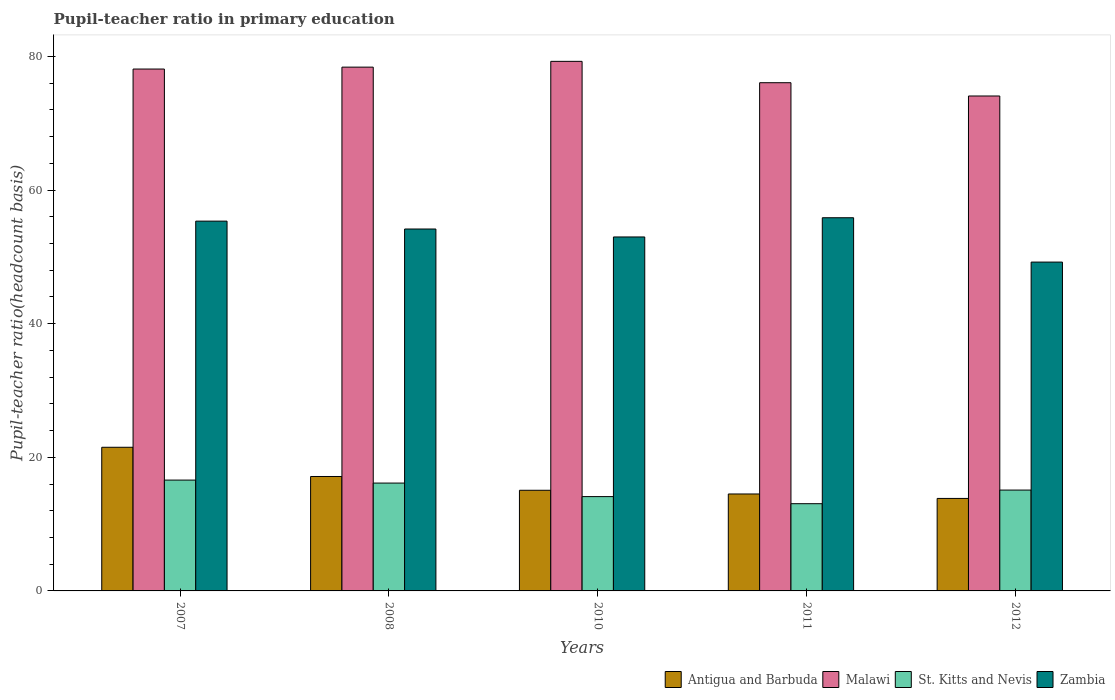How many different coloured bars are there?
Offer a very short reply. 4. Are the number of bars per tick equal to the number of legend labels?
Your response must be concise. Yes. Are the number of bars on each tick of the X-axis equal?
Provide a succinct answer. Yes. How many bars are there on the 1st tick from the left?
Keep it short and to the point. 4. What is the label of the 4th group of bars from the left?
Provide a succinct answer. 2011. What is the pupil-teacher ratio in primary education in Antigua and Barbuda in 2011?
Provide a short and direct response. 14.51. Across all years, what is the maximum pupil-teacher ratio in primary education in St. Kitts and Nevis?
Your answer should be very brief. 16.59. Across all years, what is the minimum pupil-teacher ratio in primary education in Zambia?
Provide a short and direct response. 49.22. What is the total pupil-teacher ratio in primary education in Malawi in the graph?
Offer a very short reply. 385.96. What is the difference between the pupil-teacher ratio in primary education in St. Kitts and Nevis in 2007 and that in 2010?
Your answer should be very brief. 2.47. What is the difference between the pupil-teacher ratio in primary education in Malawi in 2007 and the pupil-teacher ratio in primary education in St. Kitts and Nevis in 2010?
Provide a succinct answer. 64. What is the average pupil-teacher ratio in primary education in Malawi per year?
Keep it short and to the point. 77.19. In the year 2007, what is the difference between the pupil-teacher ratio in primary education in St. Kitts and Nevis and pupil-teacher ratio in primary education in Malawi?
Your answer should be very brief. -61.53. What is the ratio of the pupil-teacher ratio in primary education in Malawi in 2007 to that in 2010?
Offer a terse response. 0.99. What is the difference between the highest and the second highest pupil-teacher ratio in primary education in Malawi?
Offer a terse response. 0.87. What is the difference between the highest and the lowest pupil-teacher ratio in primary education in St. Kitts and Nevis?
Make the answer very short. 3.53. Is the sum of the pupil-teacher ratio in primary education in Malawi in 2008 and 2011 greater than the maximum pupil-teacher ratio in primary education in Antigua and Barbuda across all years?
Your answer should be compact. Yes. What does the 1st bar from the left in 2012 represents?
Give a very brief answer. Antigua and Barbuda. What does the 4th bar from the right in 2008 represents?
Provide a short and direct response. Antigua and Barbuda. Is it the case that in every year, the sum of the pupil-teacher ratio in primary education in Malawi and pupil-teacher ratio in primary education in St. Kitts and Nevis is greater than the pupil-teacher ratio in primary education in Antigua and Barbuda?
Ensure brevity in your answer.  Yes. Are all the bars in the graph horizontal?
Give a very brief answer. No. How many years are there in the graph?
Keep it short and to the point. 5. Does the graph contain any zero values?
Offer a terse response. No. Where does the legend appear in the graph?
Provide a short and direct response. Bottom right. How many legend labels are there?
Give a very brief answer. 4. What is the title of the graph?
Offer a terse response. Pupil-teacher ratio in primary education. Does "Aruba" appear as one of the legend labels in the graph?
Offer a terse response. No. What is the label or title of the X-axis?
Offer a terse response. Years. What is the label or title of the Y-axis?
Your response must be concise. Pupil-teacher ratio(headcount basis). What is the Pupil-teacher ratio(headcount basis) in Antigua and Barbuda in 2007?
Your answer should be compact. 21.5. What is the Pupil-teacher ratio(headcount basis) in Malawi in 2007?
Ensure brevity in your answer.  78.12. What is the Pupil-teacher ratio(headcount basis) in St. Kitts and Nevis in 2007?
Your response must be concise. 16.59. What is the Pupil-teacher ratio(headcount basis) of Zambia in 2007?
Provide a short and direct response. 55.35. What is the Pupil-teacher ratio(headcount basis) of Antigua and Barbuda in 2008?
Provide a short and direct response. 17.13. What is the Pupil-teacher ratio(headcount basis) of Malawi in 2008?
Your response must be concise. 78.41. What is the Pupil-teacher ratio(headcount basis) in St. Kitts and Nevis in 2008?
Your response must be concise. 16.14. What is the Pupil-teacher ratio(headcount basis) in Zambia in 2008?
Provide a succinct answer. 54.18. What is the Pupil-teacher ratio(headcount basis) in Antigua and Barbuda in 2010?
Keep it short and to the point. 15.07. What is the Pupil-teacher ratio(headcount basis) of Malawi in 2010?
Make the answer very short. 79.27. What is the Pupil-teacher ratio(headcount basis) of St. Kitts and Nevis in 2010?
Ensure brevity in your answer.  14.12. What is the Pupil-teacher ratio(headcount basis) of Zambia in 2010?
Provide a succinct answer. 52.99. What is the Pupil-teacher ratio(headcount basis) in Antigua and Barbuda in 2011?
Provide a succinct answer. 14.51. What is the Pupil-teacher ratio(headcount basis) of Malawi in 2011?
Offer a very short reply. 76.07. What is the Pupil-teacher ratio(headcount basis) in St. Kitts and Nevis in 2011?
Your response must be concise. 13.06. What is the Pupil-teacher ratio(headcount basis) of Zambia in 2011?
Offer a terse response. 55.86. What is the Pupil-teacher ratio(headcount basis) of Antigua and Barbuda in 2012?
Your answer should be compact. 13.85. What is the Pupil-teacher ratio(headcount basis) of Malawi in 2012?
Your response must be concise. 74.09. What is the Pupil-teacher ratio(headcount basis) in St. Kitts and Nevis in 2012?
Offer a very short reply. 15.1. What is the Pupil-teacher ratio(headcount basis) of Zambia in 2012?
Provide a succinct answer. 49.22. Across all years, what is the maximum Pupil-teacher ratio(headcount basis) of Antigua and Barbuda?
Give a very brief answer. 21.5. Across all years, what is the maximum Pupil-teacher ratio(headcount basis) in Malawi?
Your answer should be compact. 79.27. Across all years, what is the maximum Pupil-teacher ratio(headcount basis) in St. Kitts and Nevis?
Keep it short and to the point. 16.59. Across all years, what is the maximum Pupil-teacher ratio(headcount basis) in Zambia?
Offer a very short reply. 55.86. Across all years, what is the minimum Pupil-teacher ratio(headcount basis) of Antigua and Barbuda?
Keep it short and to the point. 13.85. Across all years, what is the minimum Pupil-teacher ratio(headcount basis) of Malawi?
Your answer should be very brief. 74.09. Across all years, what is the minimum Pupil-teacher ratio(headcount basis) in St. Kitts and Nevis?
Provide a succinct answer. 13.06. Across all years, what is the minimum Pupil-teacher ratio(headcount basis) of Zambia?
Ensure brevity in your answer.  49.22. What is the total Pupil-teacher ratio(headcount basis) of Antigua and Barbuda in the graph?
Your answer should be very brief. 82.06. What is the total Pupil-teacher ratio(headcount basis) in Malawi in the graph?
Keep it short and to the point. 385.96. What is the total Pupil-teacher ratio(headcount basis) of St. Kitts and Nevis in the graph?
Your answer should be very brief. 75.01. What is the total Pupil-teacher ratio(headcount basis) of Zambia in the graph?
Your answer should be compact. 267.6. What is the difference between the Pupil-teacher ratio(headcount basis) in Antigua and Barbuda in 2007 and that in 2008?
Your response must be concise. 4.37. What is the difference between the Pupil-teacher ratio(headcount basis) in Malawi in 2007 and that in 2008?
Offer a very short reply. -0.28. What is the difference between the Pupil-teacher ratio(headcount basis) in St. Kitts and Nevis in 2007 and that in 2008?
Offer a terse response. 0.45. What is the difference between the Pupil-teacher ratio(headcount basis) of Zambia in 2007 and that in 2008?
Your response must be concise. 1.18. What is the difference between the Pupil-teacher ratio(headcount basis) in Antigua and Barbuda in 2007 and that in 2010?
Offer a terse response. 6.44. What is the difference between the Pupil-teacher ratio(headcount basis) in Malawi in 2007 and that in 2010?
Keep it short and to the point. -1.15. What is the difference between the Pupil-teacher ratio(headcount basis) of St. Kitts and Nevis in 2007 and that in 2010?
Offer a terse response. 2.47. What is the difference between the Pupil-teacher ratio(headcount basis) in Zambia in 2007 and that in 2010?
Offer a terse response. 2.37. What is the difference between the Pupil-teacher ratio(headcount basis) of Antigua and Barbuda in 2007 and that in 2011?
Your response must be concise. 6.99. What is the difference between the Pupil-teacher ratio(headcount basis) of Malawi in 2007 and that in 2011?
Offer a very short reply. 2.05. What is the difference between the Pupil-teacher ratio(headcount basis) of St. Kitts and Nevis in 2007 and that in 2011?
Make the answer very short. 3.53. What is the difference between the Pupil-teacher ratio(headcount basis) in Zambia in 2007 and that in 2011?
Give a very brief answer. -0.51. What is the difference between the Pupil-teacher ratio(headcount basis) of Antigua and Barbuda in 2007 and that in 2012?
Make the answer very short. 7.66. What is the difference between the Pupil-teacher ratio(headcount basis) of Malawi in 2007 and that in 2012?
Ensure brevity in your answer.  4.04. What is the difference between the Pupil-teacher ratio(headcount basis) of St. Kitts and Nevis in 2007 and that in 2012?
Your answer should be compact. 1.5. What is the difference between the Pupil-teacher ratio(headcount basis) of Zambia in 2007 and that in 2012?
Your answer should be very brief. 6.13. What is the difference between the Pupil-teacher ratio(headcount basis) in Antigua and Barbuda in 2008 and that in 2010?
Make the answer very short. 2.06. What is the difference between the Pupil-teacher ratio(headcount basis) of Malawi in 2008 and that in 2010?
Provide a short and direct response. -0.87. What is the difference between the Pupil-teacher ratio(headcount basis) of St. Kitts and Nevis in 2008 and that in 2010?
Make the answer very short. 2.02. What is the difference between the Pupil-teacher ratio(headcount basis) of Zambia in 2008 and that in 2010?
Ensure brevity in your answer.  1.19. What is the difference between the Pupil-teacher ratio(headcount basis) in Antigua and Barbuda in 2008 and that in 2011?
Your answer should be very brief. 2.62. What is the difference between the Pupil-teacher ratio(headcount basis) of Malawi in 2008 and that in 2011?
Your answer should be compact. 2.33. What is the difference between the Pupil-teacher ratio(headcount basis) in St. Kitts and Nevis in 2008 and that in 2011?
Give a very brief answer. 3.09. What is the difference between the Pupil-teacher ratio(headcount basis) of Zambia in 2008 and that in 2011?
Keep it short and to the point. -1.69. What is the difference between the Pupil-teacher ratio(headcount basis) in Antigua and Barbuda in 2008 and that in 2012?
Keep it short and to the point. 3.28. What is the difference between the Pupil-teacher ratio(headcount basis) of Malawi in 2008 and that in 2012?
Make the answer very short. 4.32. What is the difference between the Pupil-teacher ratio(headcount basis) of St. Kitts and Nevis in 2008 and that in 2012?
Keep it short and to the point. 1.05. What is the difference between the Pupil-teacher ratio(headcount basis) in Zambia in 2008 and that in 2012?
Give a very brief answer. 4.95. What is the difference between the Pupil-teacher ratio(headcount basis) of Antigua and Barbuda in 2010 and that in 2011?
Provide a short and direct response. 0.55. What is the difference between the Pupil-teacher ratio(headcount basis) of Malawi in 2010 and that in 2011?
Ensure brevity in your answer.  3.2. What is the difference between the Pupil-teacher ratio(headcount basis) of St. Kitts and Nevis in 2010 and that in 2011?
Your response must be concise. 1.06. What is the difference between the Pupil-teacher ratio(headcount basis) of Zambia in 2010 and that in 2011?
Offer a very short reply. -2.88. What is the difference between the Pupil-teacher ratio(headcount basis) of Antigua and Barbuda in 2010 and that in 2012?
Provide a succinct answer. 1.22. What is the difference between the Pupil-teacher ratio(headcount basis) of Malawi in 2010 and that in 2012?
Offer a terse response. 5.19. What is the difference between the Pupil-teacher ratio(headcount basis) of St. Kitts and Nevis in 2010 and that in 2012?
Keep it short and to the point. -0.98. What is the difference between the Pupil-teacher ratio(headcount basis) in Zambia in 2010 and that in 2012?
Offer a very short reply. 3.76. What is the difference between the Pupil-teacher ratio(headcount basis) of Antigua and Barbuda in 2011 and that in 2012?
Offer a terse response. 0.67. What is the difference between the Pupil-teacher ratio(headcount basis) of Malawi in 2011 and that in 2012?
Keep it short and to the point. 1.99. What is the difference between the Pupil-teacher ratio(headcount basis) in St. Kitts and Nevis in 2011 and that in 2012?
Keep it short and to the point. -2.04. What is the difference between the Pupil-teacher ratio(headcount basis) in Zambia in 2011 and that in 2012?
Your answer should be very brief. 6.64. What is the difference between the Pupil-teacher ratio(headcount basis) of Antigua and Barbuda in 2007 and the Pupil-teacher ratio(headcount basis) of Malawi in 2008?
Ensure brevity in your answer.  -56.9. What is the difference between the Pupil-teacher ratio(headcount basis) of Antigua and Barbuda in 2007 and the Pupil-teacher ratio(headcount basis) of St. Kitts and Nevis in 2008?
Make the answer very short. 5.36. What is the difference between the Pupil-teacher ratio(headcount basis) in Antigua and Barbuda in 2007 and the Pupil-teacher ratio(headcount basis) in Zambia in 2008?
Provide a succinct answer. -32.67. What is the difference between the Pupil-teacher ratio(headcount basis) of Malawi in 2007 and the Pupil-teacher ratio(headcount basis) of St. Kitts and Nevis in 2008?
Your response must be concise. 61.98. What is the difference between the Pupil-teacher ratio(headcount basis) of Malawi in 2007 and the Pupil-teacher ratio(headcount basis) of Zambia in 2008?
Provide a short and direct response. 23.95. What is the difference between the Pupil-teacher ratio(headcount basis) of St. Kitts and Nevis in 2007 and the Pupil-teacher ratio(headcount basis) of Zambia in 2008?
Your answer should be compact. -37.59. What is the difference between the Pupil-teacher ratio(headcount basis) of Antigua and Barbuda in 2007 and the Pupil-teacher ratio(headcount basis) of Malawi in 2010?
Give a very brief answer. -57.77. What is the difference between the Pupil-teacher ratio(headcount basis) of Antigua and Barbuda in 2007 and the Pupil-teacher ratio(headcount basis) of St. Kitts and Nevis in 2010?
Keep it short and to the point. 7.38. What is the difference between the Pupil-teacher ratio(headcount basis) of Antigua and Barbuda in 2007 and the Pupil-teacher ratio(headcount basis) of Zambia in 2010?
Make the answer very short. -31.48. What is the difference between the Pupil-teacher ratio(headcount basis) in Malawi in 2007 and the Pupil-teacher ratio(headcount basis) in St. Kitts and Nevis in 2010?
Offer a terse response. 64. What is the difference between the Pupil-teacher ratio(headcount basis) in Malawi in 2007 and the Pupil-teacher ratio(headcount basis) in Zambia in 2010?
Your answer should be very brief. 25.14. What is the difference between the Pupil-teacher ratio(headcount basis) of St. Kitts and Nevis in 2007 and the Pupil-teacher ratio(headcount basis) of Zambia in 2010?
Keep it short and to the point. -36.39. What is the difference between the Pupil-teacher ratio(headcount basis) in Antigua and Barbuda in 2007 and the Pupil-teacher ratio(headcount basis) in Malawi in 2011?
Give a very brief answer. -54.57. What is the difference between the Pupil-teacher ratio(headcount basis) of Antigua and Barbuda in 2007 and the Pupil-teacher ratio(headcount basis) of St. Kitts and Nevis in 2011?
Your answer should be compact. 8.45. What is the difference between the Pupil-teacher ratio(headcount basis) in Antigua and Barbuda in 2007 and the Pupil-teacher ratio(headcount basis) in Zambia in 2011?
Provide a short and direct response. -34.36. What is the difference between the Pupil-teacher ratio(headcount basis) in Malawi in 2007 and the Pupil-teacher ratio(headcount basis) in St. Kitts and Nevis in 2011?
Offer a very short reply. 65.07. What is the difference between the Pupil-teacher ratio(headcount basis) of Malawi in 2007 and the Pupil-teacher ratio(headcount basis) of Zambia in 2011?
Make the answer very short. 22.26. What is the difference between the Pupil-teacher ratio(headcount basis) in St. Kitts and Nevis in 2007 and the Pupil-teacher ratio(headcount basis) in Zambia in 2011?
Provide a succinct answer. -39.27. What is the difference between the Pupil-teacher ratio(headcount basis) in Antigua and Barbuda in 2007 and the Pupil-teacher ratio(headcount basis) in Malawi in 2012?
Your answer should be compact. -52.58. What is the difference between the Pupil-teacher ratio(headcount basis) of Antigua and Barbuda in 2007 and the Pupil-teacher ratio(headcount basis) of St. Kitts and Nevis in 2012?
Offer a very short reply. 6.41. What is the difference between the Pupil-teacher ratio(headcount basis) in Antigua and Barbuda in 2007 and the Pupil-teacher ratio(headcount basis) in Zambia in 2012?
Your answer should be compact. -27.72. What is the difference between the Pupil-teacher ratio(headcount basis) in Malawi in 2007 and the Pupil-teacher ratio(headcount basis) in St. Kitts and Nevis in 2012?
Make the answer very short. 63.03. What is the difference between the Pupil-teacher ratio(headcount basis) of Malawi in 2007 and the Pupil-teacher ratio(headcount basis) of Zambia in 2012?
Your response must be concise. 28.9. What is the difference between the Pupil-teacher ratio(headcount basis) of St. Kitts and Nevis in 2007 and the Pupil-teacher ratio(headcount basis) of Zambia in 2012?
Give a very brief answer. -32.63. What is the difference between the Pupil-teacher ratio(headcount basis) in Antigua and Barbuda in 2008 and the Pupil-teacher ratio(headcount basis) in Malawi in 2010?
Provide a short and direct response. -62.14. What is the difference between the Pupil-teacher ratio(headcount basis) of Antigua and Barbuda in 2008 and the Pupil-teacher ratio(headcount basis) of St. Kitts and Nevis in 2010?
Offer a very short reply. 3.01. What is the difference between the Pupil-teacher ratio(headcount basis) in Antigua and Barbuda in 2008 and the Pupil-teacher ratio(headcount basis) in Zambia in 2010?
Your response must be concise. -35.86. What is the difference between the Pupil-teacher ratio(headcount basis) of Malawi in 2008 and the Pupil-teacher ratio(headcount basis) of St. Kitts and Nevis in 2010?
Your answer should be very brief. 64.29. What is the difference between the Pupil-teacher ratio(headcount basis) of Malawi in 2008 and the Pupil-teacher ratio(headcount basis) of Zambia in 2010?
Provide a short and direct response. 25.42. What is the difference between the Pupil-teacher ratio(headcount basis) in St. Kitts and Nevis in 2008 and the Pupil-teacher ratio(headcount basis) in Zambia in 2010?
Your answer should be very brief. -36.84. What is the difference between the Pupil-teacher ratio(headcount basis) of Antigua and Barbuda in 2008 and the Pupil-teacher ratio(headcount basis) of Malawi in 2011?
Your response must be concise. -58.94. What is the difference between the Pupil-teacher ratio(headcount basis) of Antigua and Barbuda in 2008 and the Pupil-teacher ratio(headcount basis) of St. Kitts and Nevis in 2011?
Keep it short and to the point. 4.07. What is the difference between the Pupil-teacher ratio(headcount basis) of Antigua and Barbuda in 2008 and the Pupil-teacher ratio(headcount basis) of Zambia in 2011?
Make the answer very short. -38.73. What is the difference between the Pupil-teacher ratio(headcount basis) in Malawi in 2008 and the Pupil-teacher ratio(headcount basis) in St. Kitts and Nevis in 2011?
Provide a succinct answer. 65.35. What is the difference between the Pupil-teacher ratio(headcount basis) of Malawi in 2008 and the Pupil-teacher ratio(headcount basis) of Zambia in 2011?
Ensure brevity in your answer.  22.54. What is the difference between the Pupil-teacher ratio(headcount basis) in St. Kitts and Nevis in 2008 and the Pupil-teacher ratio(headcount basis) in Zambia in 2011?
Provide a succinct answer. -39.72. What is the difference between the Pupil-teacher ratio(headcount basis) in Antigua and Barbuda in 2008 and the Pupil-teacher ratio(headcount basis) in Malawi in 2012?
Offer a very short reply. -56.96. What is the difference between the Pupil-teacher ratio(headcount basis) in Antigua and Barbuda in 2008 and the Pupil-teacher ratio(headcount basis) in St. Kitts and Nevis in 2012?
Make the answer very short. 2.03. What is the difference between the Pupil-teacher ratio(headcount basis) of Antigua and Barbuda in 2008 and the Pupil-teacher ratio(headcount basis) of Zambia in 2012?
Provide a short and direct response. -32.1. What is the difference between the Pupil-teacher ratio(headcount basis) of Malawi in 2008 and the Pupil-teacher ratio(headcount basis) of St. Kitts and Nevis in 2012?
Provide a short and direct response. 63.31. What is the difference between the Pupil-teacher ratio(headcount basis) in Malawi in 2008 and the Pupil-teacher ratio(headcount basis) in Zambia in 2012?
Offer a very short reply. 29.18. What is the difference between the Pupil-teacher ratio(headcount basis) in St. Kitts and Nevis in 2008 and the Pupil-teacher ratio(headcount basis) in Zambia in 2012?
Keep it short and to the point. -33.08. What is the difference between the Pupil-teacher ratio(headcount basis) in Antigua and Barbuda in 2010 and the Pupil-teacher ratio(headcount basis) in Malawi in 2011?
Your response must be concise. -61.01. What is the difference between the Pupil-teacher ratio(headcount basis) of Antigua and Barbuda in 2010 and the Pupil-teacher ratio(headcount basis) of St. Kitts and Nevis in 2011?
Provide a succinct answer. 2.01. What is the difference between the Pupil-teacher ratio(headcount basis) in Antigua and Barbuda in 2010 and the Pupil-teacher ratio(headcount basis) in Zambia in 2011?
Your answer should be compact. -40.8. What is the difference between the Pupil-teacher ratio(headcount basis) in Malawi in 2010 and the Pupil-teacher ratio(headcount basis) in St. Kitts and Nevis in 2011?
Offer a terse response. 66.22. What is the difference between the Pupil-teacher ratio(headcount basis) of Malawi in 2010 and the Pupil-teacher ratio(headcount basis) of Zambia in 2011?
Keep it short and to the point. 23.41. What is the difference between the Pupil-teacher ratio(headcount basis) in St. Kitts and Nevis in 2010 and the Pupil-teacher ratio(headcount basis) in Zambia in 2011?
Your answer should be very brief. -41.74. What is the difference between the Pupil-teacher ratio(headcount basis) of Antigua and Barbuda in 2010 and the Pupil-teacher ratio(headcount basis) of Malawi in 2012?
Provide a short and direct response. -59.02. What is the difference between the Pupil-teacher ratio(headcount basis) of Antigua and Barbuda in 2010 and the Pupil-teacher ratio(headcount basis) of St. Kitts and Nevis in 2012?
Your answer should be compact. -0.03. What is the difference between the Pupil-teacher ratio(headcount basis) in Antigua and Barbuda in 2010 and the Pupil-teacher ratio(headcount basis) in Zambia in 2012?
Provide a succinct answer. -34.16. What is the difference between the Pupil-teacher ratio(headcount basis) in Malawi in 2010 and the Pupil-teacher ratio(headcount basis) in St. Kitts and Nevis in 2012?
Keep it short and to the point. 64.18. What is the difference between the Pupil-teacher ratio(headcount basis) in Malawi in 2010 and the Pupil-teacher ratio(headcount basis) in Zambia in 2012?
Your response must be concise. 30.05. What is the difference between the Pupil-teacher ratio(headcount basis) in St. Kitts and Nevis in 2010 and the Pupil-teacher ratio(headcount basis) in Zambia in 2012?
Offer a terse response. -35.1. What is the difference between the Pupil-teacher ratio(headcount basis) of Antigua and Barbuda in 2011 and the Pupil-teacher ratio(headcount basis) of Malawi in 2012?
Ensure brevity in your answer.  -59.57. What is the difference between the Pupil-teacher ratio(headcount basis) in Antigua and Barbuda in 2011 and the Pupil-teacher ratio(headcount basis) in St. Kitts and Nevis in 2012?
Keep it short and to the point. -0.58. What is the difference between the Pupil-teacher ratio(headcount basis) in Antigua and Barbuda in 2011 and the Pupil-teacher ratio(headcount basis) in Zambia in 2012?
Your answer should be compact. -34.71. What is the difference between the Pupil-teacher ratio(headcount basis) of Malawi in 2011 and the Pupil-teacher ratio(headcount basis) of St. Kitts and Nevis in 2012?
Your response must be concise. 60.98. What is the difference between the Pupil-teacher ratio(headcount basis) of Malawi in 2011 and the Pupil-teacher ratio(headcount basis) of Zambia in 2012?
Give a very brief answer. 26.85. What is the difference between the Pupil-teacher ratio(headcount basis) of St. Kitts and Nevis in 2011 and the Pupil-teacher ratio(headcount basis) of Zambia in 2012?
Offer a very short reply. -36.17. What is the average Pupil-teacher ratio(headcount basis) of Antigua and Barbuda per year?
Offer a terse response. 16.41. What is the average Pupil-teacher ratio(headcount basis) in Malawi per year?
Provide a short and direct response. 77.19. What is the average Pupil-teacher ratio(headcount basis) of St. Kitts and Nevis per year?
Offer a very short reply. 15. What is the average Pupil-teacher ratio(headcount basis) in Zambia per year?
Provide a short and direct response. 53.52. In the year 2007, what is the difference between the Pupil-teacher ratio(headcount basis) in Antigua and Barbuda and Pupil-teacher ratio(headcount basis) in Malawi?
Your answer should be compact. -56.62. In the year 2007, what is the difference between the Pupil-teacher ratio(headcount basis) of Antigua and Barbuda and Pupil-teacher ratio(headcount basis) of St. Kitts and Nevis?
Offer a terse response. 4.91. In the year 2007, what is the difference between the Pupil-teacher ratio(headcount basis) of Antigua and Barbuda and Pupil-teacher ratio(headcount basis) of Zambia?
Offer a very short reply. -33.85. In the year 2007, what is the difference between the Pupil-teacher ratio(headcount basis) of Malawi and Pupil-teacher ratio(headcount basis) of St. Kitts and Nevis?
Give a very brief answer. 61.53. In the year 2007, what is the difference between the Pupil-teacher ratio(headcount basis) of Malawi and Pupil-teacher ratio(headcount basis) of Zambia?
Your answer should be very brief. 22.77. In the year 2007, what is the difference between the Pupil-teacher ratio(headcount basis) of St. Kitts and Nevis and Pupil-teacher ratio(headcount basis) of Zambia?
Make the answer very short. -38.76. In the year 2008, what is the difference between the Pupil-teacher ratio(headcount basis) of Antigua and Barbuda and Pupil-teacher ratio(headcount basis) of Malawi?
Ensure brevity in your answer.  -61.28. In the year 2008, what is the difference between the Pupil-teacher ratio(headcount basis) in Antigua and Barbuda and Pupil-teacher ratio(headcount basis) in St. Kitts and Nevis?
Offer a terse response. 0.98. In the year 2008, what is the difference between the Pupil-teacher ratio(headcount basis) of Antigua and Barbuda and Pupil-teacher ratio(headcount basis) of Zambia?
Offer a terse response. -37.05. In the year 2008, what is the difference between the Pupil-teacher ratio(headcount basis) in Malawi and Pupil-teacher ratio(headcount basis) in St. Kitts and Nevis?
Keep it short and to the point. 62.26. In the year 2008, what is the difference between the Pupil-teacher ratio(headcount basis) of Malawi and Pupil-teacher ratio(headcount basis) of Zambia?
Ensure brevity in your answer.  24.23. In the year 2008, what is the difference between the Pupil-teacher ratio(headcount basis) in St. Kitts and Nevis and Pupil-teacher ratio(headcount basis) in Zambia?
Give a very brief answer. -38.03. In the year 2010, what is the difference between the Pupil-teacher ratio(headcount basis) of Antigua and Barbuda and Pupil-teacher ratio(headcount basis) of Malawi?
Your answer should be very brief. -64.21. In the year 2010, what is the difference between the Pupil-teacher ratio(headcount basis) of Antigua and Barbuda and Pupil-teacher ratio(headcount basis) of St. Kitts and Nevis?
Make the answer very short. 0.95. In the year 2010, what is the difference between the Pupil-teacher ratio(headcount basis) in Antigua and Barbuda and Pupil-teacher ratio(headcount basis) in Zambia?
Offer a terse response. -37.92. In the year 2010, what is the difference between the Pupil-teacher ratio(headcount basis) of Malawi and Pupil-teacher ratio(headcount basis) of St. Kitts and Nevis?
Your answer should be compact. 65.15. In the year 2010, what is the difference between the Pupil-teacher ratio(headcount basis) of Malawi and Pupil-teacher ratio(headcount basis) of Zambia?
Your response must be concise. 26.29. In the year 2010, what is the difference between the Pupil-teacher ratio(headcount basis) in St. Kitts and Nevis and Pupil-teacher ratio(headcount basis) in Zambia?
Provide a short and direct response. -38.87. In the year 2011, what is the difference between the Pupil-teacher ratio(headcount basis) in Antigua and Barbuda and Pupil-teacher ratio(headcount basis) in Malawi?
Offer a terse response. -61.56. In the year 2011, what is the difference between the Pupil-teacher ratio(headcount basis) of Antigua and Barbuda and Pupil-teacher ratio(headcount basis) of St. Kitts and Nevis?
Make the answer very short. 1.46. In the year 2011, what is the difference between the Pupil-teacher ratio(headcount basis) in Antigua and Barbuda and Pupil-teacher ratio(headcount basis) in Zambia?
Keep it short and to the point. -41.35. In the year 2011, what is the difference between the Pupil-teacher ratio(headcount basis) in Malawi and Pupil-teacher ratio(headcount basis) in St. Kitts and Nevis?
Your answer should be very brief. 63.02. In the year 2011, what is the difference between the Pupil-teacher ratio(headcount basis) of Malawi and Pupil-teacher ratio(headcount basis) of Zambia?
Make the answer very short. 20.21. In the year 2011, what is the difference between the Pupil-teacher ratio(headcount basis) in St. Kitts and Nevis and Pupil-teacher ratio(headcount basis) in Zambia?
Offer a terse response. -42.81. In the year 2012, what is the difference between the Pupil-teacher ratio(headcount basis) in Antigua and Barbuda and Pupil-teacher ratio(headcount basis) in Malawi?
Offer a very short reply. -60.24. In the year 2012, what is the difference between the Pupil-teacher ratio(headcount basis) in Antigua and Barbuda and Pupil-teacher ratio(headcount basis) in St. Kitts and Nevis?
Ensure brevity in your answer.  -1.25. In the year 2012, what is the difference between the Pupil-teacher ratio(headcount basis) in Antigua and Barbuda and Pupil-teacher ratio(headcount basis) in Zambia?
Offer a terse response. -35.38. In the year 2012, what is the difference between the Pupil-teacher ratio(headcount basis) of Malawi and Pupil-teacher ratio(headcount basis) of St. Kitts and Nevis?
Your answer should be very brief. 58.99. In the year 2012, what is the difference between the Pupil-teacher ratio(headcount basis) in Malawi and Pupil-teacher ratio(headcount basis) in Zambia?
Your response must be concise. 24.86. In the year 2012, what is the difference between the Pupil-teacher ratio(headcount basis) of St. Kitts and Nevis and Pupil-teacher ratio(headcount basis) of Zambia?
Your answer should be very brief. -34.13. What is the ratio of the Pupil-teacher ratio(headcount basis) in Antigua and Barbuda in 2007 to that in 2008?
Keep it short and to the point. 1.26. What is the ratio of the Pupil-teacher ratio(headcount basis) of Malawi in 2007 to that in 2008?
Offer a very short reply. 1. What is the ratio of the Pupil-teacher ratio(headcount basis) in St. Kitts and Nevis in 2007 to that in 2008?
Provide a short and direct response. 1.03. What is the ratio of the Pupil-teacher ratio(headcount basis) of Zambia in 2007 to that in 2008?
Keep it short and to the point. 1.02. What is the ratio of the Pupil-teacher ratio(headcount basis) of Antigua and Barbuda in 2007 to that in 2010?
Give a very brief answer. 1.43. What is the ratio of the Pupil-teacher ratio(headcount basis) of Malawi in 2007 to that in 2010?
Offer a very short reply. 0.99. What is the ratio of the Pupil-teacher ratio(headcount basis) of St. Kitts and Nevis in 2007 to that in 2010?
Keep it short and to the point. 1.18. What is the ratio of the Pupil-teacher ratio(headcount basis) of Zambia in 2007 to that in 2010?
Offer a terse response. 1.04. What is the ratio of the Pupil-teacher ratio(headcount basis) of Antigua and Barbuda in 2007 to that in 2011?
Make the answer very short. 1.48. What is the ratio of the Pupil-teacher ratio(headcount basis) in Malawi in 2007 to that in 2011?
Keep it short and to the point. 1.03. What is the ratio of the Pupil-teacher ratio(headcount basis) of St. Kitts and Nevis in 2007 to that in 2011?
Offer a very short reply. 1.27. What is the ratio of the Pupil-teacher ratio(headcount basis) of Zambia in 2007 to that in 2011?
Keep it short and to the point. 0.99. What is the ratio of the Pupil-teacher ratio(headcount basis) of Antigua and Barbuda in 2007 to that in 2012?
Your response must be concise. 1.55. What is the ratio of the Pupil-teacher ratio(headcount basis) in Malawi in 2007 to that in 2012?
Your response must be concise. 1.05. What is the ratio of the Pupil-teacher ratio(headcount basis) in St. Kitts and Nevis in 2007 to that in 2012?
Your answer should be compact. 1.1. What is the ratio of the Pupil-teacher ratio(headcount basis) of Zambia in 2007 to that in 2012?
Ensure brevity in your answer.  1.12. What is the ratio of the Pupil-teacher ratio(headcount basis) in Antigua and Barbuda in 2008 to that in 2010?
Your answer should be compact. 1.14. What is the ratio of the Pupil-teacher ratio(headcount basis) in Malawi in 2008 to that in 2010?
Your answer should be compact. 0.99. What is the ratio of the Pupil-teacher ratio(headcount basis) of St. Kitts and Nevis in 2008 to that in 2010?
Your response must be concise. 1.14. What is the ratio of the Pupil-teacher ratio(headcount basis) of Zambia in 2008 to that in 2010?
Provide a succinct answer. 1.02. What is the ratio of the Pupil-teacher ratio(headcount basis) of Antigua and Barbuda in 2008 to that in 2011?
Provide a succinct answer. 1.18. What is the ratio of the Pupil-teacher ratio(headcount basis) in Malawi in 2008 to that in 2011?
Your answer should be compact. 1.03. What is the ratio of the Pupil-teacher ratio(headcount basis) of St. Kitts and Nevis in 2008 to that in 2011?
Offer a terse response. 1.24. What is the ratio of the Pupil-teacher ratio(headcount basis) of Zambia in 2008 to that in 2011?
Your answer should be very brief. 0.97. What is the ratio of the Pupil-teacher ratio(headcount basis) in Antigua and Barbuda in 2008 to that in 2012?
Your answer should be very brief. 1.24. What is the ratio of the Pupil-teacher ratio(headcount basis) of Malawi in 2008 to that in 2012?
Your answer should be very brief. 1.06. What is the ratio of the Pupil-teacher ratio(headcount basis) of St. Kitts and Nevis in 2008 to that in 2012?
Offer a very short reply. 1.07. What is the ratio of the Pupil-teacher ratio(headcount basis) in Zambia in 2008 to that in 2012?
Give a very brief answer. 1.1. What is the ratio of the Pupil-teacher ratio(headcount basis) of Antigua and Barbuda in 2010 to that in 2011?
Keep it short and to the point. 1.04. What is the ratio of the Pupil-teacher ratio(headcount basis) in Malawi in 2010 to that in 2011?
Make the answer very short. 1.04. What is the ratio of the Pupil-teacher ratio(headcount basis) in St. Kitts and Nevis in 2010 to that in 2011?
Your response must be concise. 1.08. What is the ratio of the Pupil-teacher ratio(headcount basis) of Zambia in 2010 to that in 2011?
Your answer should be compact. 0.95. What is the ratio of the Pupil-teacher ratio(headcount basis) in Antigua and Barbuda in 2010 to that in 2012?
Give a very brief answer. 1.09. What is the ratio of the Pupil-teacher ratio(headcount basis) of Malawi in 2010 to that in 2012?
Keep it short and to the point. 1.07. What is the ratio of the Pupil-teacher ratio(headcount basis) of St. Kitts and Nevis in 2010 to that in 2012?
Give a very brief answer. 0.94. What is the ratio of the Pupil-teacher ratio(headcount basis) of Zambia in 2010 to that in 2012?
Make the answer very short. 1.08. What is the ratio of the Pupil-teacher ratio(headcount basis) in Antigua and Barbuda in 2011 to that in 2012?
Keep it short and to the point. 1.05. What is the ratio of the Pupil-teacher ratio(headcount basis) of Malawi in 2011 to that in 2012?
Provide a succinct answer. 1.03. What is the ratio of the Pupil-teacher ratio(headcount basis) of St. Kitts and Nevis in 2011 to that in 2012?
Give a very brief answer. 0.86. What is the ratio of the Pupil-teacher ratio(headcount basis) in Zambia in 2011 to that in 2012?
Offer a terse response. 1.13. What is the difference between the highest and the second highest Pupil-teacher ratio(headcount basis) of Antigua and Barbuda?
Your response must be concise. 4.37. What is the difference between the highest and the second highest Pupil-teacher ratio(headcount basis) in Malawi?
Your answer should be compact. 0.87. What is the difference between the highest and the second highest Pupil-teacher ratio(headcount basis) of St. Kitts and Nevis?
Provide a succinct answer. 0.45. What is the difference between the highest and the second highest Pupil-teacher ratio(headcount basis) in Zambia?
Your answer should be compact. 0.51. What is the difference between the highest and the lowest Pupil-teacher ratio(headcount basis) in Antigua and Barbuda?
Provide a succinct answer. 7.66. What is the difference between the highest and the lowest Pupil-teacher ratio(headcount basis) of Malawi?
Keep it short and to the point. 5.19. What is the difference between the highest and the lowest Pupil-teacher ratio(headcount basis) of St. Kitts and Nevis?
Your answer should be very brief. 3.53. What is the difference between the highest and the lowest Pupil-teacher ratio(headcount basis) in Zambia?
Your answer should be compact. 6.64. 